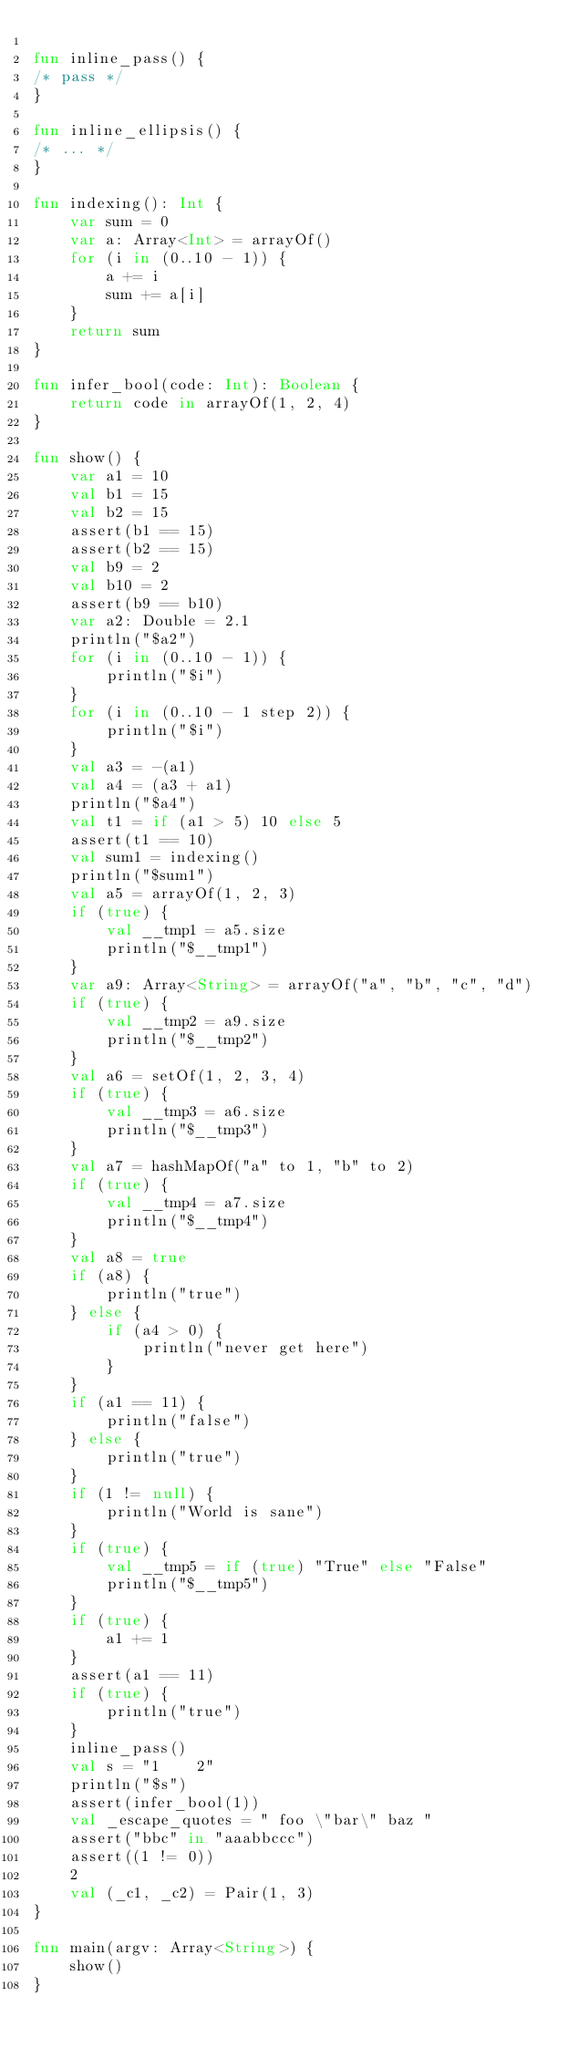<code> <loc_0><loc_0><loc_500><loc_500><_Kotlin_>
fun inline_pass() {
/* pass */
}

fun inline_ellipsis() {
/* ... */
}

fun indexing(): Int {
    var sum = 0
    var a: Array<Int> = arrayOf()
    for (i in (0..10 - 1)) {
        a += i
        sum += a[i]
    }
    return sum
}

fun infer_bool(code: Int): Boolean {
    return code in arrayOf(1, 2, 4)
}

fun show() {
    var a1 = 10
    val b1 = 15
    val b2 = 15
    assert(b1 == 15)
    assert(b2 == 15)
    val b9 = 2
    val b10 = 2
    assert(b9 == b10)
    var a2: Double = 2.1
    println("$a2")
    for (i in (0..10 - 1)) {
        println("$i")
    }
    for (i in (0..10 - 1 step 2)) {
        println("$i")
    }
    val a3 = -(a1)
    val a4 = (a3 + a1)
    println("$a4")
    val t1 = if (a1 > 5) 10 else 5
    assert(t1 == 10)
    val sum1 = indexing()
    println("$sum1")
    val a5 = arrayOf(1, 2, 3)
    if (true) {
        val __tmp1 = a5.size
        println("$__tmp1")
    }
    var a9: Array<String> = arrayOf("a", "b", "c", "d")
    if (true) {
        val __tmp2 = a9.size
        println("$__tmp2")
    }
    val a6 = setOf(1, 2, 3, 4)
    if (true) {
        val __tmp3 = a6.size
        println("$__tmp3")
    }
    val a7 = hashMapOf("a" to 1, "b" to 2)
    if (true) {
        val __tmp4 = a7.size
        println("$__tmp4")
    }
    val a8 = true
    if (a8) {
        println("true")
    } else {
        if (a4 > 0) {
            println("never get here")
        }
    }
    if (a1 == 11) {
        println("false")
    } else {
        println("true")
    }
    if (1 != null) {
        println("World is sane")
    }
    if (true) {
        val __tmp5 = if (true) "True" else "False"
        println("$__tmp5")
    }
    if (true) {
        a1 += 1
    }
    assert(a1 == 11)
    if (true) {
        println("true")
    }
    inline_pass()
    val s = "1    2"
    println("$s")
    assert(infer_bool(1))
    val _escape_quotes = " foo \"bar\" baz "
    assert("bbc" in "aaabbccc")
    assert((1 != 0))
    2
    val (_c1, _c2) = Pair(1, 3)
}

fun main(argv: Array<String>) {
    show()
}
</code> 